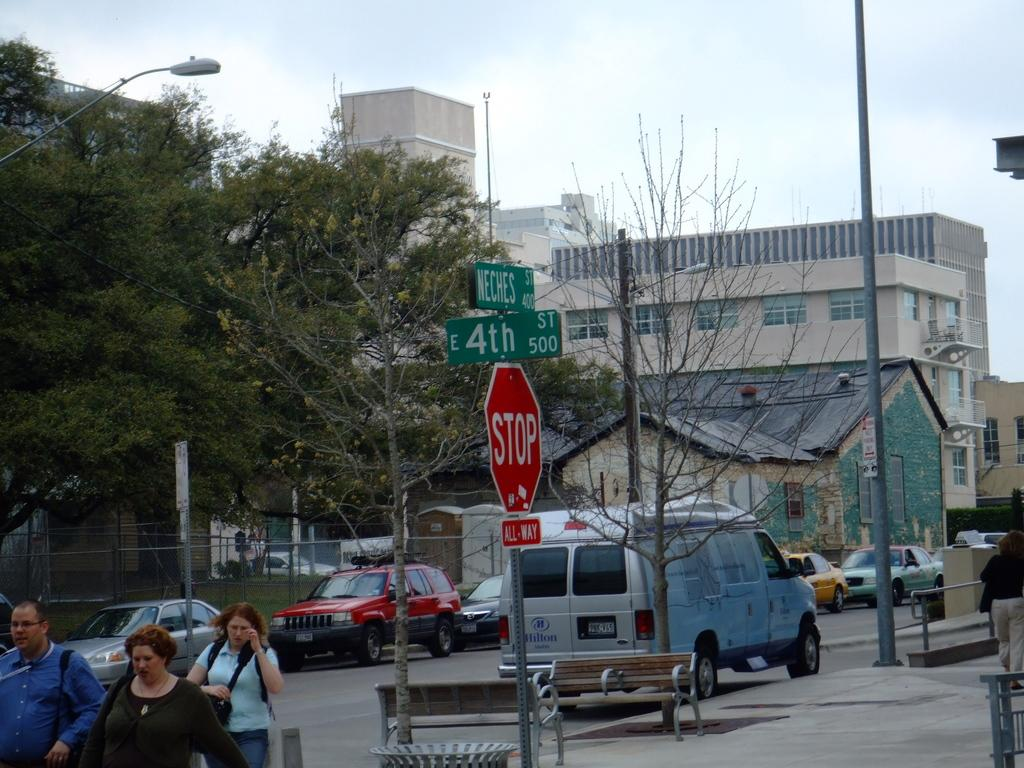What type of objects can be seen in the image that provide information or directions? There are sign boards in the image that provide information or directions. What type of objects can be seen in the image that people use for transportation? There are vehicles in the image that people use for transportation. What type of objects can be seen in the image that are used for support or construction? Metal rods are visible in the image that are used for support or construction. What type of objects can be seen in the image that people use for sitting? There are benches in the image that people use for sitting. What type of objects can be seen in the image that indicate the presence of people? There is a group of people in the image. What type of objects can be seen in the background of the image that provide shade or natural beauty? Trees are present in the background of the image that provide shade or natural beauty. What type of objects can be seen in the background of the image that are used for support or visibility? Poles are visible in the background of the image that are used for support or visibility. What type of objects can be seen in the background of the image that provide illumination? Lights are present in the background of the image that provide illumination. What type of objects can be seen in the background of the image that indicate human development or habitation? Buildings are visible in the background of the image that indicate human development or habitation. What type of bread can be seen in the image? There is no loaf of bread present in the image. What type of holiday drink can be seen in the image? There is no eggnog present in the image. 